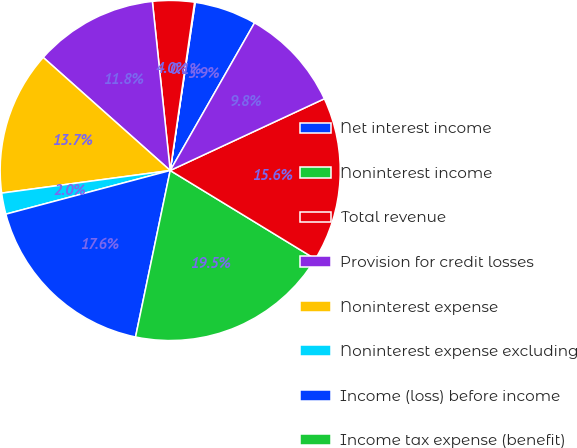Convert chart. <chart><loc_0><loc_0><loc_500><loc_500><pie_chart><fcel>Net interest income<fcel>Noninterest income<fcel>Total revenue<fcel>Provision for credit losses<fcel>Noninterest expense<fcel>Noninterest expense excluding<fcel>Income (loss) before income<fcel>Income tax expense (benefit)<fcel>Net income (loss)<fcel>Net income excluding goodwill<nl><fcel>5.91%<fcel>0.06%<fcel>3.96%<fcel>11.75%<fcel>13.7%<fcel>2.01%<fcel>17.6%<fcel>19.55%<fcel>15.65%<fcel>9.81%<nl></chart> 